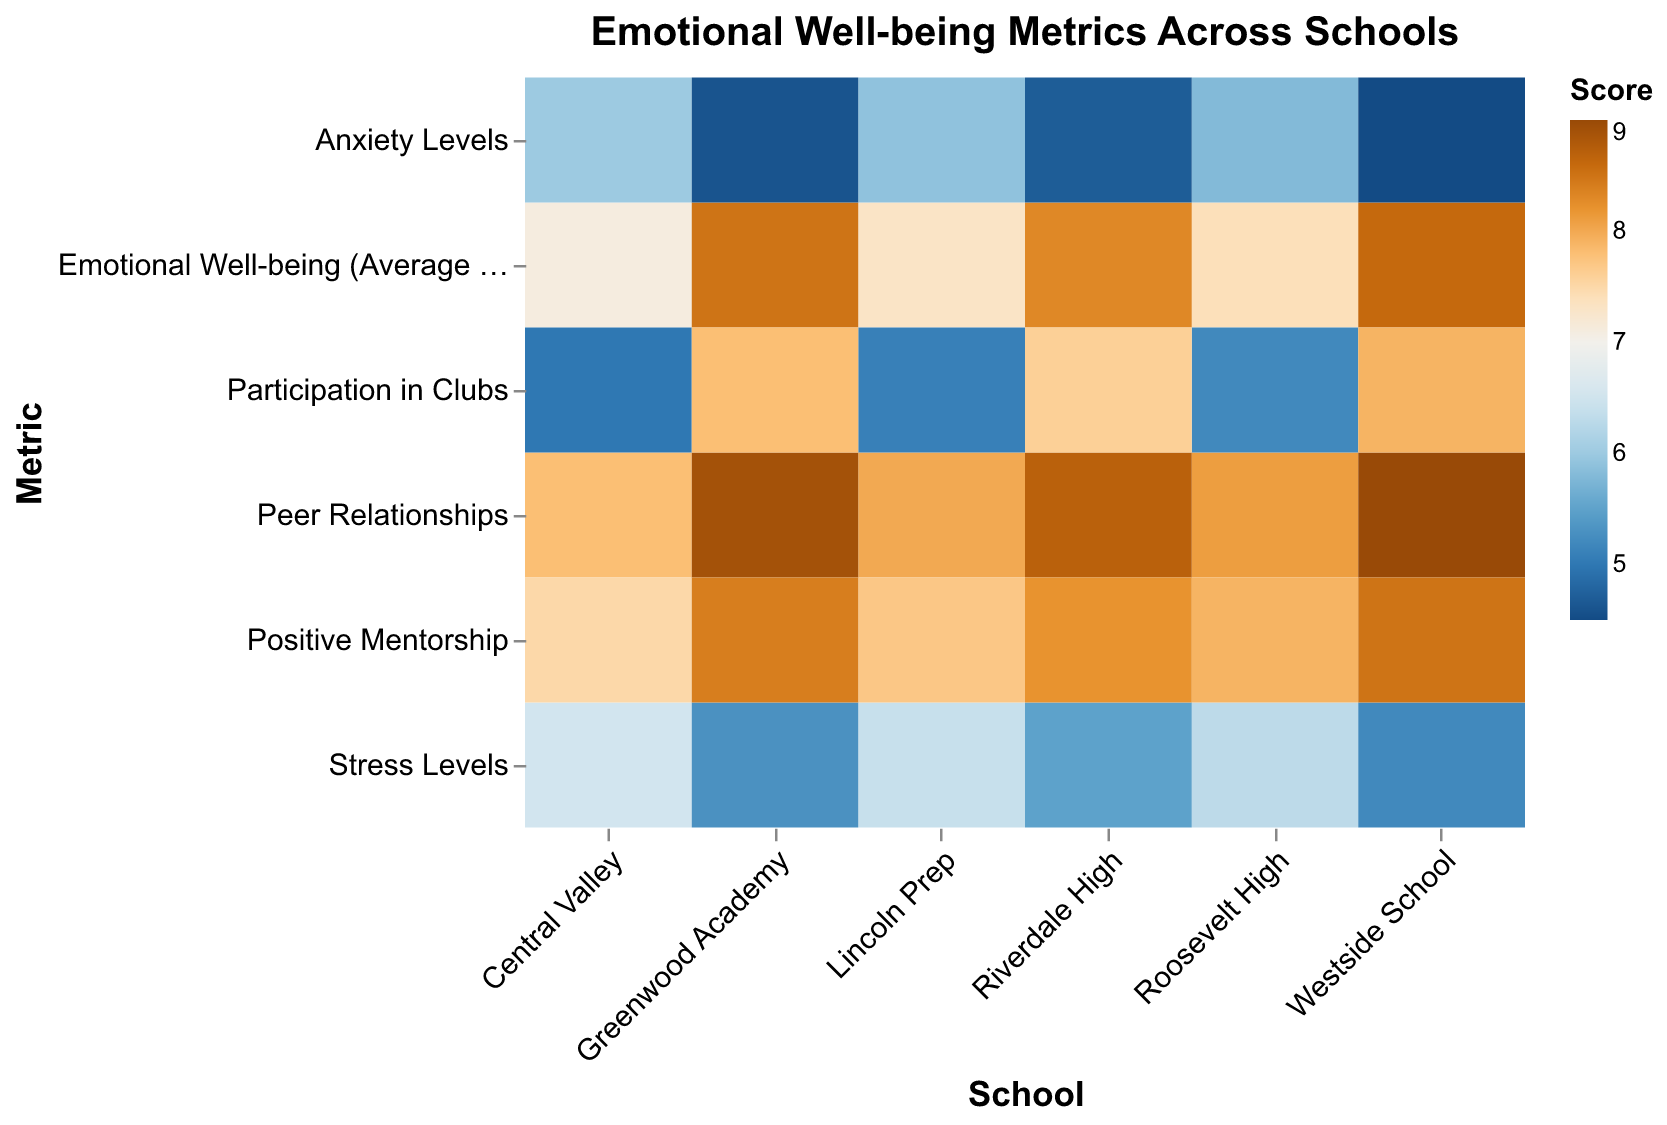How many schools are analyzed in this heatmap? To find the number of schools, look for discrete columns or unique names corresponding to different schools on the x-axis. In this figure, there are 6 unique school names.
Answer: 6 What is the title of the heatmap? The title of the heatmap is typically displayed at the top of the chart. For this heatmap, it reads "Emotional Well-being Metrics Across Schools."
Answer: Emotional Well-being Metrics Across Schools Which school from the Heavy Sports Program has the highest Emotional Well-being (Average Score)? Examine the color intensity related to Emotional Well-being (Average Score) for schools with a Heavy Sports Program. Roosevelt High scored 7.4, Central Valley scored 7.1, and Lincoln Prep scored 7.3. Therefore, Roosevelt High has the highest score.
Answer: Roosevelt High Which program type shows lower average Stress Levels across the schools? Compare the Stress Levels for Animal Rights Club (5.3, 5.5, 5.2) and Heavy Sports Program (6.3, 6.5, 6.4). The mean for Animal Rights Club is approximately 5.33 and for Heavy Sports Program is 6.4. Hence, Animal Rights Club has lower Stress Levels.
Answer: Animal Rights Club What are the Participation in Clubs scores for Riverdale High and Central Valley? Look for the Participation in Clubs row for the respective schools. Riverdale High has a score of 7.6 and Central Valley has a score of 5.0.
Answer: 7.6 and 5.0 Which metric has the highest value for Westside School? Analyze the color intensity in the row corresponding to Westside School. The highest value of 9.0 appears for Peer Relationships.
Answer: Peer Relationships Is the Anxiety Levels score generally higher in schools with a Heavy Sports Program than in schools with Animal Rights Clubs? By comparing the Anxiety Levels scores, Heavy Sports Program schools have scores of 5.8, 6.0, and 5.9. Animal Rights Club schools have scores of 4.6, 4.7, and 4.5. Hence, Anxiety Levels are generally higher in schools with Heavy Sports Programs.
Answer: Yes What is the difference in Emotional Well-being (Average Score) between Greenwood Academy and Lincoln Prep? Difference calculation is: 8.5 (Greenwood Academy) - 7.3 (Lincoln Prep) = 1.2.
Answer: 1.2 Which school has the lowest Peer Relationships score and what is that score? Among the schools, Central Valley has the lowest Peer Relationships score of 7.8.
Answer: Central Valley, 7.8 